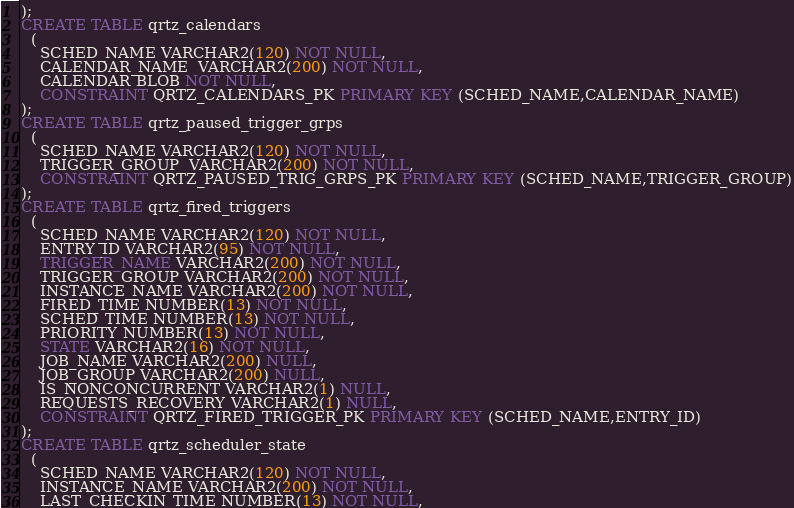Convert code to text. <code><loc_0><loc_0><loc_500><loc_500><_SQL_>);
CREATE TABLE qrtz_calendars
  (
    SCHED_NAME VARCHAR2(120) NOT NULL,
    CALENDAR_NAME  VARCHAR2(200) NOT NULL, 
    CALENDAR BLOB NOT NULL,
    CONSTRAINT QRTZ_CALENDARS_PK PRIMARY KEY (SCHED_NAME,CALENDAR_NAME)
);
CREATE TABLE qrtz_paused_trigger_grps
  (
    SCHED_NAME VARCHAR2(120) NOT NULL,
    TRIGGER_GROUP  VARCHAR2(200) NOT NULL, 
    CONSTRAINT QRTZ_PAUSED_TRIG_GRPS_PK PRIMARY KEY (SCHED_NAME,TRIGGER_GROUP)
);
CREATE TABLE qrtz_fired_triggers 
  (
    SCHED_NAME VARCHAR2(120) NOT NULL,
    ENTRY_ID VARCHAR2(95) NOT NULL,
    TRIGGER_NAME VARCHAR2(200) NOT NULL,
    TRIGGER_GROUP VARCHAR2(200) NOT NULL,
    INSTANCE_NAME VARCHAR2(200) NOT NULL,
    FIRED_TIME NUMBER(13) NOT NULL,
    SCHED_TIME NUMBER(13) NOT NULL,
    PRIORITY NUMBER(13) NOT NULL,
    STATE VARCHAR2(16) NOT NULL,
    JOB_NAME VARCHAR2(200) NULL,
    JOB_GROUP VARCHAR2(200) NULL,
    IS_NONCONCURRENT VARCHAR2(1) NULL,
    REQUESTS_RECOVERY VARCHAR2(1) NULL,
    CONSTRAINT QRTZ_FIRED_TRIGGER_PK PRIMARY KEY (SCHED_NAME,ENTRY_ID)
);
CREATE TABLE qrtz_scheduler_state 
  (
    SCHED_NAME VARCHAR2(120) NOT NULL,
    INSTANCE_NAME VARCHAR2(200) NOT NULL,
    LAST_CHECKIN_TIME NUMBER(13) NOT NULL,</code> 